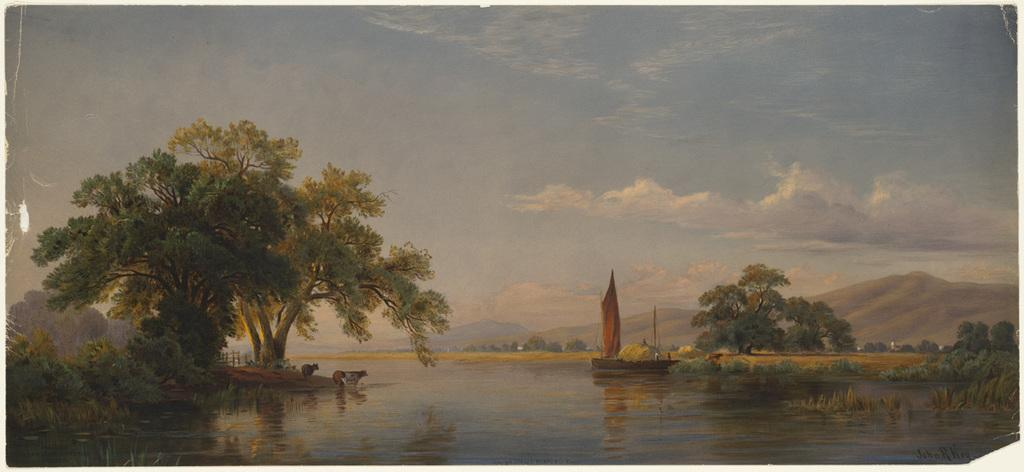What is the main feature of the image? The main feature of the image is water. What can be seen on either side of the water? There are trees and plants on either side of the water. What is visible in the background of the image? There are mountains in the background of the image. How would you describe the sky in the image? The sky is visible in the image and it is a bit cloudy. What type of leather is being used to make a fork in the image? There is no leather or fork present in the image. What religious symbol can be seen in the image? There is no religious symbol present in the image. 